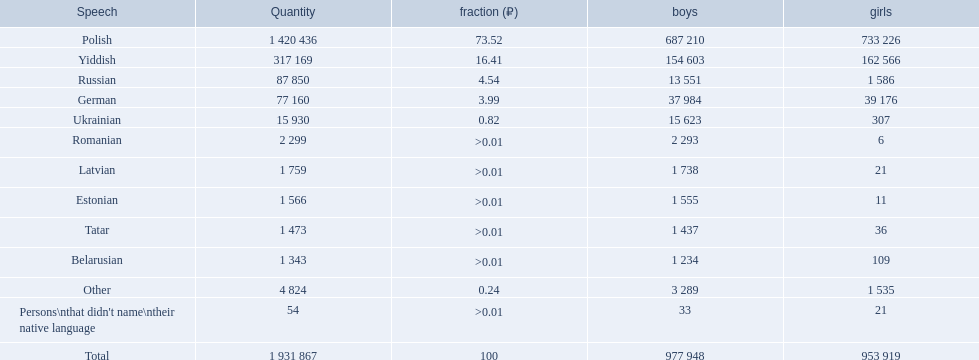What are all of the languages Polish, Yiddish, Russian, German, Ukrainian, Romanian, Latvian, Estonian, Tatar, Belarusian, Other, Persons\nthat didn't name\ntheir native language. Parse the full table. {'header': ['Speech', 'Quantity', 'fraction (₽)', 'boys', 'girls'], 'rows': [['Polish', '1 420 436', '73.52', '687 210', '733 226'], ['Yiddish', '317 169', '16.41', '154 603', '162 566'], ['Russian', '87 850', '4.54', '13 551', '1 586'], ['German', '77 160', '3.99', '37 984', '39 176'], ['Ukrainian', '15 930', '0.82', '15 623', '307'], ['Romanian', '2 299', '>0.01', '2 293', '6'], ['Latvian', '1 759', '>0.01', '1 738', '21'], ['Estonian', '1 566', '>0.01', '1 555', '11'], ['Tatar', '1 473', '>0.01', '1 437', '36'], ['Belarusian', '1 343', '>0.01', '1 234', '109'], ['Other', '4 824', '0.24', '3 289', '1 535'], ["Persons\\nthat didn't name\\ntheir native language", '54', '>0.01', '33', '21'], ['Total', '1 931 867', '100', '977 948', '953 919']]} What was the percentage of each? 73.52, 16.41, 4.54, 3.99, 0.82, >0.01, >0.01, >0.01, >0.01, >0.01, 0.24, >0.01. Which languages had a >0.01	 percentage? Romanian, Latvian, Estonian, Tatar, Belarusian. And of those, which is listed first? Romanian. 